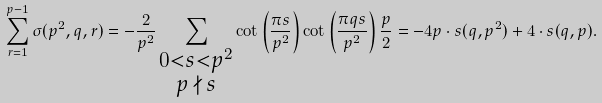<formula> <loc_0><loc_0><loc_500><loc_500>\sum _ { r = 1 } ^ { p - 1 } \sigma ( p ^ { 2 } , q , r ) = - \frac { 2 } { p ^ { 2 } } \sum _ { \substack { 0 < s < p ^ { 2 } \\ p \, \nmid \, s } } \cot \left ( \frac { \pi s } { p ^ { 2 } } \right ) \cot \left ( \frac { \pi q s } { p ^ { 2 } } \right ) \frac { p } { 2 } = - 4 p \cdot s ( q , p ^ { 2 } ) + 4 \cdot s ( q , p ) .</formula> 